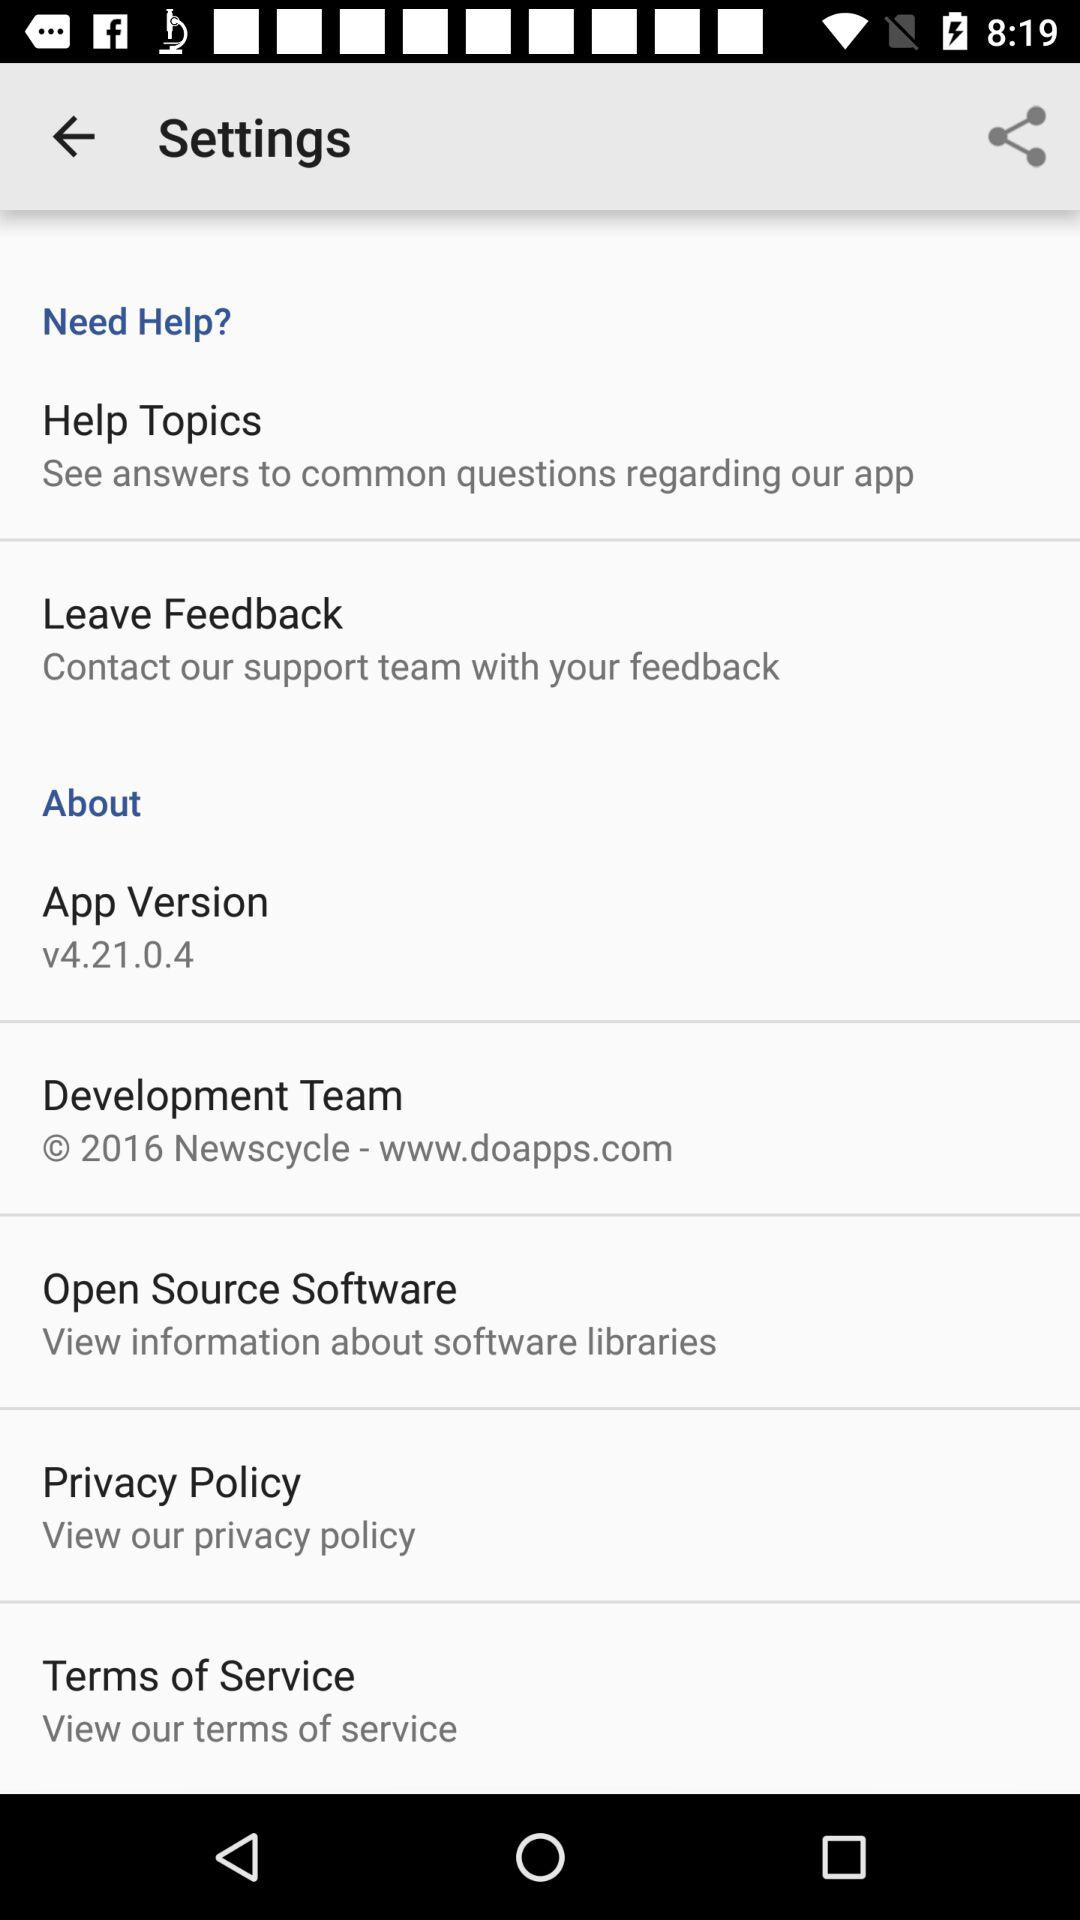What is the URL for contacting the development team? The URL for contacting the development team is www.doapps.com. 